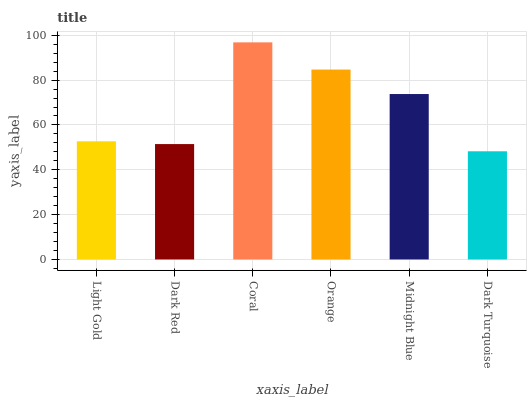Is Dark Red the minimum?
Answer yes or no. No. Is Dark Red the maximum?
Answer yes or no. No. Is Light Gold greater than Dark Red?
Answer yes or no. Yes. Is Dark Red less than Light Gold?
Answer yes or no. Yes. Is Dark Red greater than Light Gold?
Answer yes or no. No. Is Light Gold less than Dark Red?
Answer yes or no. No. Is Midnight Blue the high median?
Answer yes or no. Yes. Is Light Gold the low median?
Answer yes or no. Yes. Is Orange the high median?
Answer yes or no. No. Is Orange the low median?
Answer yes or no. No. 